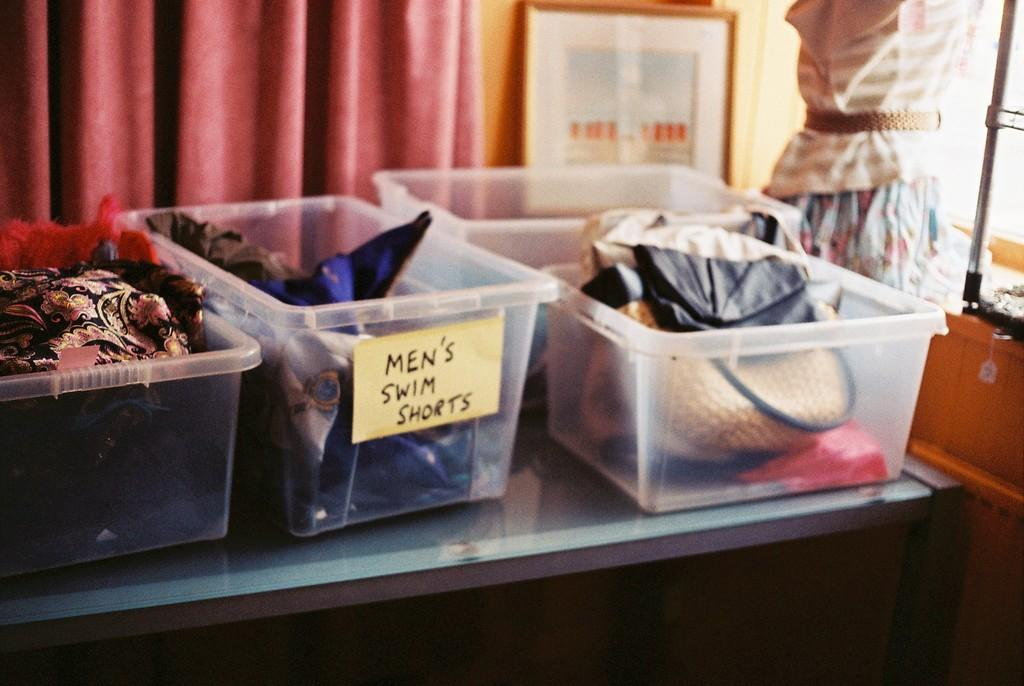<image>
Offer a succinct explanation of the picture presented. Plastic bins with stuff in them, one labeled Men's Swim Suits. 